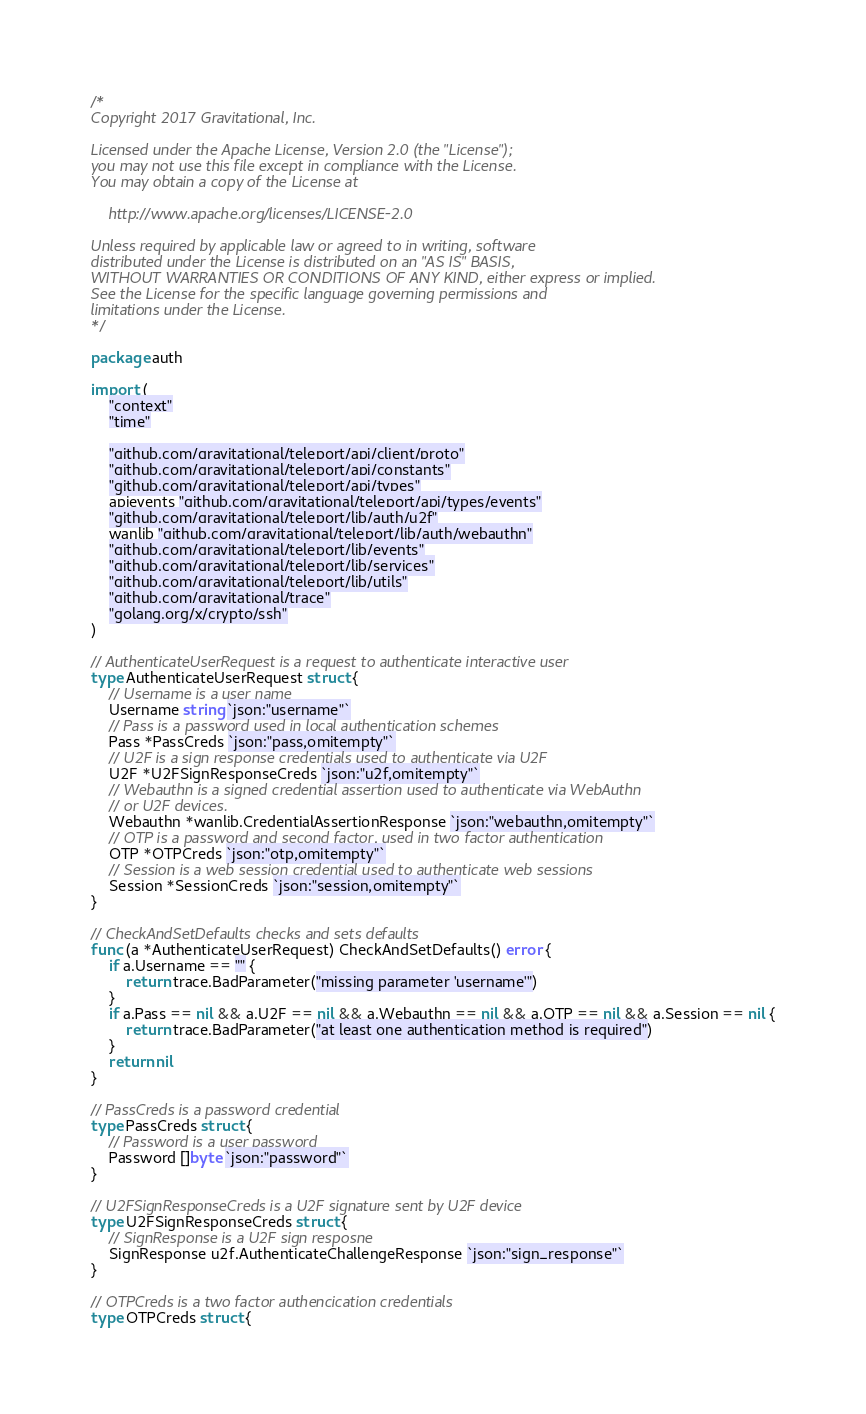<code> <loc_0><loc_0><loc_500><loc_500><_Go_>/*
Copyright 2017 Gravitational, Inc.

Licensed under the Apache License, Version 2.0 (the "License");
you may not use this file except in compliance with the License.
You may obtain a copy of the License at

    http://www.apache.org/licenses/LICENSE-2.0

Unless required by applicable law or agreed to in writing, software
distributed under the License is distributed on an "AS IS" BASIS,
WITHOUT WARRANTIES OR CONDITIONS OF ANY KIND, either express or implied.
See the License for the specific language governing permissions and
limitations under the License.
*/

package auth

import (
	"context"
	"time"

	"github.com/gravitational/teleport/api/client/proto"
	"github.com/gravitational/teleport/api/constants"
	"github.com/gravitational/teleport/api/types"
	apievents "github.com/gravitational/teleport/api/types/events"
	"github.com/gravitational/teleport/lib/auth/u2f"
	wanlib "github.com/gravitational/teleport/lib/auth/webauthn"
	"github.com/gravitational/teleport/lib/events"
	"github.com/gravitational/teleport/lib/services"
	"github.com/gravitational/teleport/lib/utils"
	"github.com/gravitational/trace"
	"golang.org/x/crypto/ssh"
)

// AuthenticateUserRequest is a request to authenticate interactive user
type AuthenticateUserRequest struct {
	// Username is a user name
	Username string `json:"username"`
	// Pass is a password used in local authentication schemes
	Pass *PassCreds `json:"pass,omitempty"`
	// U2F is a sign response credentials used to authenticate via U2F
	U2F *U2FSignResponseCreds `json:"u2f,omitempty"`
	// Webauthn is a signed credential assertion used to authenticate via WebAuthn
	// or U2F devices.
	Webauthn *wanlib.CredentialAssertionResponse `json:"webauthn,omitempty"`
	// OTP is a password and second factor, used in two factor authentication
	OTP *OTPCreds `json:"otp,omitempty"`
	// Session is a web session credential used to authenticate web sessions
	Session *SessionCreds `json:"session,omitempty"`
}

// CheckAndSetDefaults checks and sets defaults
func (a *AuthenticateUserRequest) CheckAndSetDefaults() error {
	if a.Username == "" {
		return trace.BadParameter("missing parameter 'username'")
	}
	if a.Pass == nil && a.U2F == nil && a.Webauthn == nil && a.OTP == nil && a.Session == nil {
		return trace.BadParameter("at least one authentication method is required")
	}
	return nil
}

// PassCreds is a password credential
type PassCreds struct {
	// Password is a user password
	Password []byte `json:"password"`
}

// U2FSignResponseCreds is a U2F signature sent by U2F device
type U2FSignResponseCreds struct {
	// SignResponse is a U2F sign resposne
	SignResponse u2f.AuthenticateChallengeResponse `json:"sign_response"`
}

// OTPCreds is a two factor authencication credentials
type OTPCreds struct {</code> 